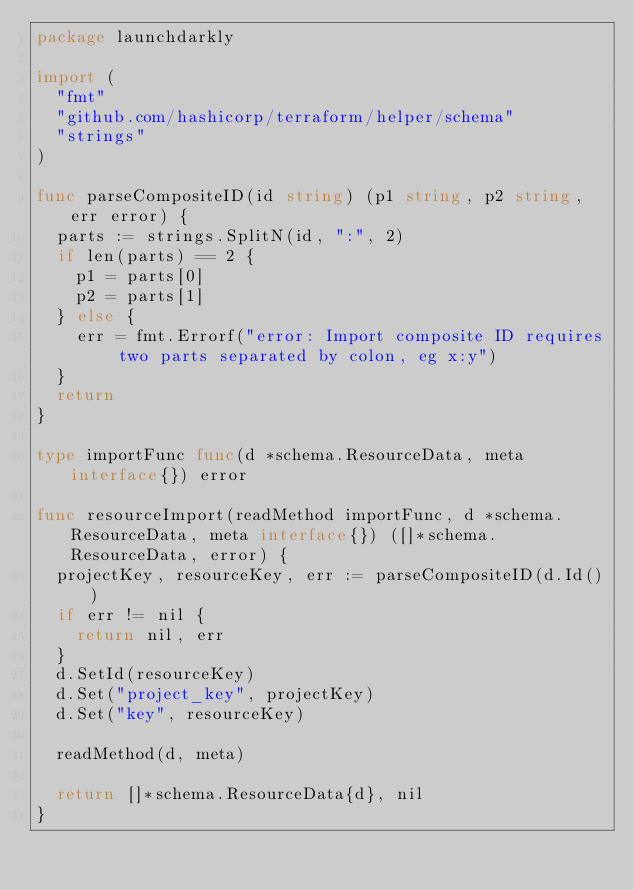Convert code to text. <code><loc_0><loc_0><loc_500><loc_500><_Go_>package launchdarkly

import (
	"fmt"
	"github.com/hashicorp/terraform/helper/schema"
	"strings"
)

func parseCompositeID(id string) (p1 string, p2 string, err error) {
	parts := strings.SplitN(id, ":", 2)
	if len(parts) == 2 {
		p1 = parts[0]
		p2 = parts[1]
	} else {
		err = fmt.Errorf("error: Import composite ID requires two parts separated by colon, eg x:y")
	}
	return
}

type importFunc func(d *schema.ResourceData, meta interface{}) error

func resourceImport(readMethod importFunc, d *schema.ResourceData, meta interface{}) ([]*schema.ResourceData, error) {
	projectKey, resourceKey, err := parseCompositeID(d.Id())
	if err != nil {
		return nil, err
	}
	d.SetId(resourceKey)
	d.Set("project_key", projectKey)
	d.Set("key", resourceKey)

	readMethod(d, meta)

	return []*schema.ResourceData{d}, nil
}
</code> 